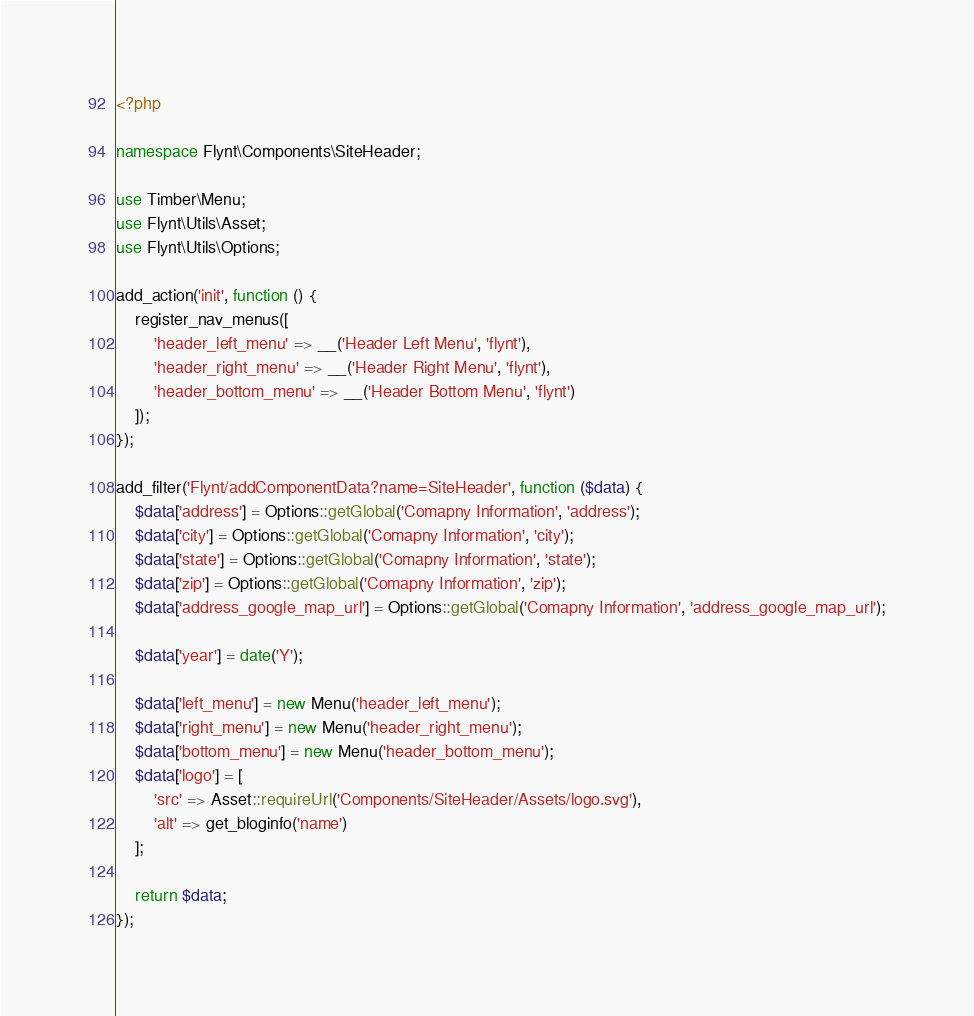Convert code to text. <code><loc_0><loc_0><loc_500><loc_500><_PHP_><?php

namespace Flynt\Components\SiteHeader;

use Timber\Menu;
use Flynt\Utils\Asset;
use Flynt\Utils\Options;

add_action('init', function () {
    register_nav_menus([
        'header_left_menu' => __('Header Left Menu', 'flynt'),
        'header_right_menu' => __('Header Right Menu', 'flynt'),
        'header_bottom_menu' => __('Header Bottom Menu', 'flynt')
    ]);
});

add_filter('Flynt/addComponentData?name=SiteHeader', function ($data) {
    $data['address'] = Options::getGlobal('Comapny Information', 'address');
    $data['city'] = Options::getGlobal('Comapny Information', 'city');
    $data['state'] = Options::getGlobal('Comapny Information', 'state');
    $data['zip'] = Options::getGlobal('Comapny Information', 'zip');
    $data['address_google_map_url'] = Options::getGlobal('Comapny Information', 'address_google_map_url');

    $data['year'] = date('Y');
    
    $data['left_menu'] = new Menu('header_left_menu');
    $data['right_menu'] = new Menu('header_right_menu');
    $data['bottom_menu'] = new Menu('header_bottom_menu');
    $data['logo'] = [
        'src' => Asset::requireUrl('Components/SiteHeader/Assets/logo.svg'),
        'alt' => get_bloginfo('name')
    ];

    return $data;
});
</code> 